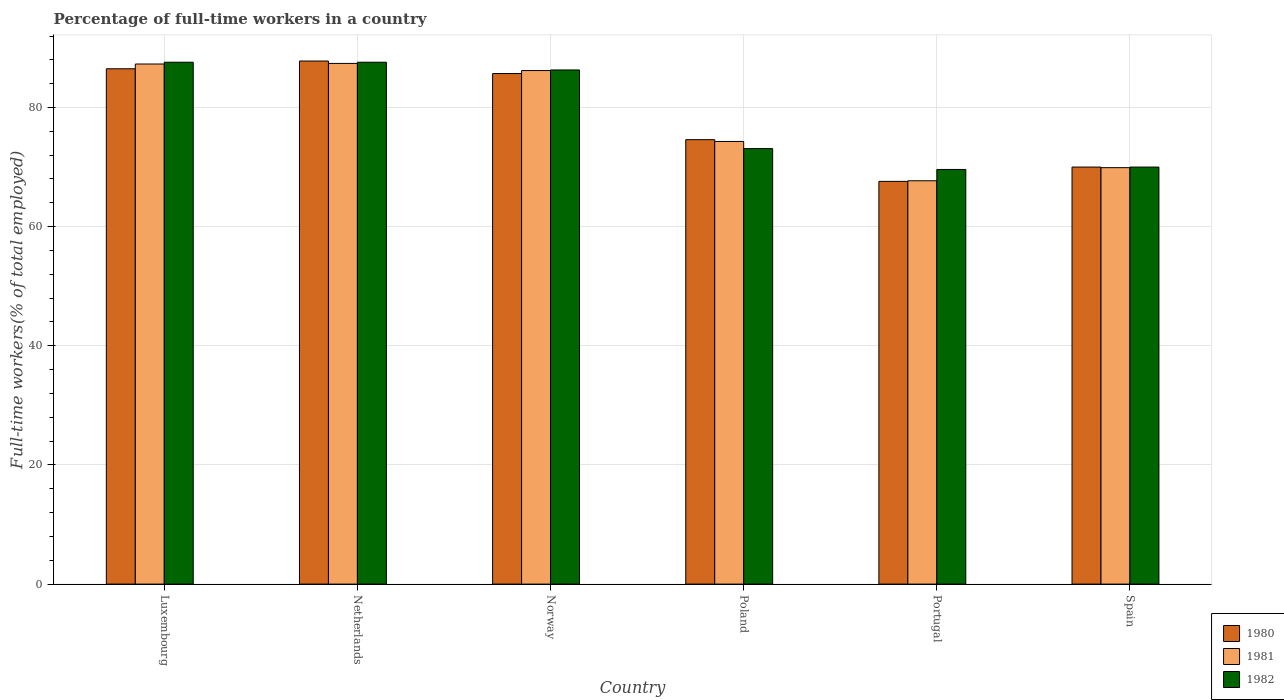How many different coloured bars are there?
Keep it short and to the point. 3. How many bars are there on the 6th tick from the right?
Provide a succinct answer. 3. What is the label of the 4th group of bars from the left?
Offer a very short reply. Poland. What is the percentage of full-time workers in 1982 in Norway?
Your answer should be very brief. 86.3. Across all countries, what is the maximum percentage of full-time workers in 1982?
Make the answer very short. 87.6. Across all countries, what is the minimum percentage of full-time workers in 1981?
Make the answer very short. 67.7. In which country was the percentage of full-time workers in 1982 maximum?
Provide a succinct answer. Luxembourg. In which country was the percentage of full-time workers in 1980 minimum?
Offer a very short reply. Portugal. What is the total percentage of full-time workers in 1981 in the graph?
Your response must be concise. 472.8. What is the difference between the percentage of full-time workers in 1980 in Norway and that in Spain?
Your answer should be compact. 15.7. What is the difference between the percentage of full-time workers in 1980 in Spain and the percentage of full-time workers in 1981 in Poland?
Give a very brief answer. -4.3. What is the average percentage of full-time workers in 1980 per country?
Provide a succinct answer. 78.7. What is the difference between the percentage of full-time workers of/in 1981 and percentage of full-time workers of/in 1980 in Portugal?
Provide a succinct answer. 0.1. What is the ratio of the percentage of full-time workers in 1980 in Poland to that in Spain?
Your response must be concise. 1.07. Is the percentage of full-time workers in 1981 in Luxembourg less than that in Spain?
Your response must be concise. No. What is the difference between the highest and the second highest percentage of full-time workers in 1981?
Offer a very short reply. -1.1. What is the difference between the highest and the lowest percentage of full-time workers in 1981?
Give a very brief answer. 19.7. What does the 3rd bar from the right in Luxembourg represents?
Make the answer very short. 1980. How many bars are there?
Offer a very short reply. 18. Are all the bars in the graph horizontal?
Offer a very short reply. No. Are the values on the major ticks of Y-axis written in scientific E-notation?
Make the answer very short. No. How are the legend labels stacked?
Offer a terse response. Vertical. What is the title of the graph?
Your answer should be compact. Percentage of full-time workers in a country. What is the label or title of the X-axis?
Offer a very short reply. Country. What is the label or title of the Y-axis?
Your answer should be very brief. Full-time workers(% of total employed). What is the Full-time workers(% of total employed) of 1980 in Luxembourg?
Ensure brevity in your answer.  86.5. What is the Full-time workers(% of total employed) of 1981 in Luxembourg?
Keep it short and to the point. 87.3. What is the Full-time workers(% of total employed) in 1982 in Luxembourg?
Provide a succinct answer. 87.6. What is the Full-time workers(% of total employed) of 1980 in Netherlands?
Provide a short and direct response. 87.8. What is the Full-time workers(% of total employed) of 1981 in Netherlands?
Offer a terse response. 87.4. What is the Full-time workers(% of total employed) of 1982 in Netherlands?
Provide a short and direct response. 87.6. What is the Full-time workers(% of total employed) in 1980 in Norway?
Offer a terse response. 85.7. What is the Full-time workers(% of total employed) in 1981 in Norway?
Ensure brevity in your answer.  86.2. What is the Full-time workers(% of total employed) in 1982 in Norway?
Provide a succinct answer. 86.3. What is the Full-time workers(% of total employed) in 1980 in Poland?
Provide a short and direct response. 74.6. What is the Full-time workers(% of total employed) of 1981 in Poland?
Ensure brevity in your answer.  74.3. What is the Full-time workers(% of total employed) of 1982 in Poland?
Provide a succinct answer. 73.1. What is the Full-time workers(% of total employed) in 1980 in Portugal?
Give a very brief answer. 67.6. What is the Full-time workers(% of total employed) in 1981 in Portugal?
Provide a succinct answer. 67.7. What is the Full-time workers(% of total employed) of 1982 in Portugal?
Your response must be concise. 69.6. What is the Full-time workers(% of total employed) of 1980 in Spain?
Your answer should be compact. 70. What is the Full-time workers(% of total employed) in 1981 in Spain?
Offer a very short reply. 69.9. What is the Full-time workers(% of total employed) of 1982 in Spain?
Provide a short and direct response. 70. Across all countries, what is the maximum Full-time workers(% of total employed) in 1980?
Provide a short and direct response. 87.8. Across all countries, what is the maximum Full-time workers(% of total employed) of 1981?
Offer a terse response. 87.4. Across all countries, what is the maximum Full-time workers(% of total employed) of 1982?
Provide a short and direct response. 87.6. Across all countries, what is the minimum Full-time workers(% of total employed) in 1980?
Offer a terse response. 67.6. Across all countries, what is the minimum Full-time workers(% of total employed) of 1981?
Ensure brevity in your answer.  67.7. Across all countries, what is the minimum Full-time workers(% of total employed) in 1982?
Provide a short and direct response. 69.6. What is the total Full-time workers(% of total employed) of 1980 in the graph?
Make the answer very short. 472.2. What is the total Full-time workers(% of total employed) of 1981 in the graph?
Your answer should be very brief. 472.8. What is the total Full-time workers(% of total employed) in 1982 in the graph?
Your answer should be very brief. 474.2. What is the difference between the Full-time workers(% of total employed) of 1980 in Luxembourg and that in Netherlands?
Give a very brief answer. -1.3. What is the difference between the Full-time workers(% of total employed) in 1981 in Luxembourg and that in Netherlands?
Your response must be concise. -0.1. What is the difference between the Full-time workers(% of total employed) of 1980 in Luxembourg and that in Norway?
Give a very brief answer. 0.8. What is the difference between the Full-time workers(% of total employed) of 1981 in Luxembourg and that in Norway?
Offer a very short reply. 1.1. What is the difference between the Full-time workers(% of total employed) of 1980 in Luxembourg and that in Poland?
Offer a very short reply. 11.9. What is the difference between the Full-time workers(% of total employed) in 1981 in Luxembourg and that in Poland?
Provide a succinct answer. 13. What is the difference between the Full-time workers(% of total employed) in 1982 in Luxembourg and that in Poland?
Give a very brief answer. 14.5. What is the difference between the Full-time workers(% of total employed) in 1980 in Luxembourg and that in Portugal?
Ensure brevity in your answer.  18.9. What is the difference between the Full-time workers(% of total employed) of 1981 in Luxembourg and that in Portugal?
Keep it short and to the point. 19.6. What is the difference between the Full-time workers(% of total employed) of 1982 in Luxembourg and that in Portugal?
Provide a short and direct response. 18. What is the difference between the Full-time workers(% of total employed) in 1981 in Luxembourg and that in Spain?
Offer a terse response. 17.4. What is the difference between the Full-time workers(% of total employed) in 1982 in Luxembourg and that in Spain?
Give a very brief answer. 17.6. What is the difference between the Full-time workers(% of total employed) of 1980 in Netherlands and that in Norway?
Your response must be concise. 2.1. What is the difference between the Full-time workers(% of total employed) in 1982 in Netherlands and that in Norway?
Give a very brief answer. 1.3. What is the difference between the Full-time workers(% of total employed) in 1980 in Netherlands and that in Poland?
Your answer should be compact. 13.2. What is the difference between the Full-time workers(% of total employed) of 1981 in Netherlands and that in Poland?
Keep it short and to the point. 13.1. What is the difference between the Full-time workers(% of total employed) in 1980 in Netherlands and that in Portugal?
Provide a short and direct response. 20.2. What is the difference between the Full-time workers(% of total employed) of 1981 in Netherlands and that in Portugal?
Your response must be concise. 19.7. What is the difference between the Full-time workers(% of total employed) in 1982 in Netherlands and that in Portugal?
Offer a very short reply. 18. What is the difference between the Full-time workers(% of total employed) of 1981 in Netherlands and that in Spain?
Offer a terse response. 17.5. What is the difference between the Full-time workers(% of total employed) of 1980 in Norway and that in Poland?
Offer a very short reply. 11.1. What is the difference between the Full-time workers(% of total employed) in 1982 in Norway and that in Poland?
Give a very brief answer. 13.2. What is the difference between the Full-time workers(% of total employed) of 1982 in Norway and that in Portugal?
Keep it short and to the point. 16.7. What is the difference between the Full-time workers(% of total employed) in 1980 in Poland and that in Portugal?
Keep it short and to the point. 7. What is the difference between the Full-time workers(% of total employed) of 1981 in Poland and that in Spain?
Keep it short and to the point. 4.4. What is the difference between the Full-time workers(% of total employed) in 1980 in Portugal and that in Spain?
Offer a very short reply. -2.4. What is the difference between the Full-time workers(% of total employed) of 1981 in Portugal and that in Spain?
Give a very brief answer. -2.2. What is the difference between the Full-time workers(% of total employed) in 1982 in Portugal and that in Spain?
Your answer should be compact. -0.4. What is the difference between the Full-time workers(% of total employed) of 1980 in Luxembourg and the Full-time workers(% of total employed) of 1981 in Netherlands?
Provide a short and direct response. -0.9. What is the difference between the Full-time workers(% of total employed) in 1980 in Luxembourg and the Full-time workers(% of total employed) in 1981 in Norway?
Offer a very short reply. 0.3. What is the difference between the Full-time workers(% of total employed) in 1980 in Luxembourg and the Full-time workers(% of total employed) in 1982 in Norway?
Your answer should be compact. 0.2. What is the difference between the Full-time workers(% of total employed) in 1981 in Luxembourg and the Full-time workers(% of total employed) in 1982 in Norway?
Give a very brief answer. 1. What is the difference between the Full-time workers(% of total employed) of 1980 in Luxembourg and the Full-time workers(% of total employed) of 1982 in Poland?
Give a very brief answer. 13.4. What is the difference between the Full-time workers(% of total employed) in 1981 in Luxembourg and the Full-time workers(% of total employed) in 1982 in Poland?
Your answer should be compact. 14.2. What is the difference between the Full-time workers(% of total employed) of 1980 in Luxembourg and the Full-time workers(% of total employed) of 1981 in Portugal?
Provide a succinct answer. 18.8. What is the difference between the Full-time workers(% of total employed) of 1981 in Luxembourg and the Full-time workers(% of total employed) of 1982 in Portugal?
Provide a succinct answer. 17.7. What is the difference between the Full-time workers(% of total employed) of 1980 in Netherlands and the Full-time workers(% of total employed) of 1982 in Norway?
Your answer should be compact. 1.5. What is the difference between the Full-time workers(% of total employed) in 1980 in Netherlands and the Full-time workers(% of total employed) in 1981 in Poland?
Ensure brevity in your answer.  13.5. What is the difference between the Full-time workers(% of total employed) in 1981 in Netherlands and the Full-time workers(% of total employed) in 1982 in Poland?
Make the answer very short. 14.3. What is the difference between the Full-time workers(% of total employed) of 1980 in Netherlands and the Full-time workers(% of total employed) of 1981 in Portugal?
Offer a terse response. 20.1. What is the difference between the Full-time workers(% of total employed) in 1981 in Netherlands and the Full-time workers(% of total employed) in 1982 in Portugal?
Your response must be concise. 17.8. What is the difference between the Full-time workers(% of total employed) in 1980 in Netherlands and the Full-time workers(% of total employed) in 1981 in Spain?
Provide a short and direct response. 17.9. What is the difference between the Full-time workers(% of total employed) of 1980 in Norway and the Full-time workers(% of total employed) of 1982 in Poland?
Offer a terse response. 12.6. What is the difference between the Full-time workers(% of total employed) of 1980 in Norway and the Full-time workers(% of total employed) of 1982 in Portugal?
Make the answer very short. 16.1. What is the difference between the Full-time workers(% of total employed) in 1981 in Norway and the Full-time workers(% of total employed) in 1982 in Portugal?
Your answer should be very brief. 16.6. What is the difference between the Full-time workers(% of total employed) in 1981 in Norway and the Full-time workers(% of total employed) in 1982 in Spain?
Ensure brevity in your answer.  16.2. What is the difference between the Full-time workers(% of total employed) in 1980 in Poland and the Full-time workers(% of total employed) in 1982 in Portugal?
Give a very brief answer. 5. What is the difference between the Full-time workers(% of total employed) of 1980 in Poland and the Full-time workers(% of total employed) of 1981 in Spain?
Keep it short and to the point. 4.7. What is the difference between the Full-time workers(% of total employed) in 1980 in Portugal and the Full-time workers(% of total employed) in 1981 in Spain?
Your answer should be very brief. -2.3. What is the difference between the Full-time workers(% of total employed) of 1981 in Portugal and the Full-time workers(% of total employed) of 1982 in Spain?
Your response must be concise. -2.3. What is the average Full-time workers(% of total employed) in 1980 per country?
Keep it short and to the point. 78.7. What is the average Full-time workers(% of total employed) in 1981 per country?
Offer a very short reply. 78.8. What is the average Full-time workers(% of total employed) of 1982 per country?
Provide a short and direct response. 79.03. What is the difference between the Full-time workers(% of total employed) in 1980 and Full-time workers(% of total employed) in 1981 in Luxembourg?
Keep it short and to the point. -0.8. What is the difference between the Full-time workers(% of total employed) of 1980 and Full-time workers(% of total employed) of 1982 in Luxembourg?
Your answer should be compact. -1.1. What is the difference between the Full-time workers(% of total employed) of 1981 and Full-time workers(% of total employed) of 1982 in Luxembourg?
Your answer should be compact. -0.3. What is the difference between the Full-time workers(% of total employed) in 1981 and Full-time workers(% of total employed) in 1982 in Netherlands?
Offer a terse response. -0.2. What is the difference between the Full-time workers(% of total employed) of 1980 and Full-time workers(% of total employed) of 1982 in Norway?
Give a very brief answer. -0.6. What is the difference between the Full-time workers(% of total employed) in 1981 and Full-time workers(% of total employed) in 1982 in Norway?
Ensure brevity in your answer.  -0.1. What is the difference between the Full-time workers(% of total employed) in 1980 and Full-time workers(% of total employed) in 1981 in Poland?
Your answer should be compact. 0.3. What is the difference between the Full-time workers(% of total employed) in 1980 and Full-time workers(% of total employed) in 1982 in Poland?
Ensure brevity in your answer.  1.5. What is the difference between the Full-time workers(% of total employed) in 1980 and Full-time workers(% of total employed) in 1982 in Portugal?
Make the answer very short. -2. What is the difference between the Full-time workers(% of total employed) in 1981 and Full-time workers(% of total employed) in 1982 in Spain?
Give a very brief answer. -0.1. What is the ratio of the Full-time workers(% of total employed) in 1980 in Luxembourg to that in Netherlands?
Make the answer very short. 0.99. What is the ratio of the Full-time workers(% of total employed) in 1980 in Luxembourg to that in Norway?
Give a very brief answer. 1.01. What is the ratio of the Full-time workers(% of total employed) in 1981 in Luxembourg to that in Norway?
Your answer should be compact. 1.01. What is the ratio of the Full-time workers(% of total employed) in 1982 in Luxembourg to that in Norway?
Your answer should be compact. 1.02. What is the ratio of the Full-time workers(% of total employed) of 1980 in Luxembourg to that in Poland?
Give a very brief answer. 1.16. What is the ratio of the Full-time workers(% of total employed) in 1981 in Luxembourg to that in Poland?
Provide a short and direct response. 1.18. What is the ratio of the Full-time workers(% of total employed) in 1982 in Luxembourg to that in Poland?
Give a very brief answer. 1.2. What is the ratio of the Full-time workers(% of total employed) of 1980 in Luxembourg to that in Portugal?
Keep it short and to the point. 1.28. What is the ratio of the Full-time workers(% of total employed) of 1981 in Luxembourg to that in Portugal?
Provide a succinct answer. 1.29. What is the ratio of the Full-time workers(% of total employed) in 1982 in Luxembourg to that in Portugal?
Keep it short and to the point. 1.26. What is the ratio of the Full-time workers(% of total employed) of 1980 in Luxembourg to that in Spain?
Provide a short and direct response. 1.24. What is the ratio of the Full-time workers(% of total employed) in 1981 in Luxembourg to that in Spain?
Your response must be concise. 1.25. What is the ratio of the Full-time workers(% of total employed) in 1982 in Luxembourg to that in Spain?
Offer a terse response. 1.25. What is the ratio of the Full-time workers(% of total employed) in 1980 in Netherlands to that in Norway?
Offer a very short reply. 1.02. What is the ratio of the Full-time workers(% of total employed) in 1981 in Netherlands to that in Norway?
Give a very brief answer. 1.01. What is the ratio of the Full-time workers(% of total employed) in 1982 in Netherlands to that in Norway?
Make the answer very short. 1.02. What is the ratio of the Full-time workers(% of total employed) in 1980 in Netherlands to that in Poland?
Your answer should be compact. 1.18. What is the ratio of the Full-time workers(% of total employed) in 1981 in Netherlands to that in Poland?
Give a very brief answer. 1.18. What is the ratio of the Full-time workers(% of total employed) in 1982 in Netherlands to that in Poland?
Offer a terse response. 1.2. What is the ratio of the Full-time workers(% of total employed) of 1980 in Netherlands to that in Portugal?
Provide a short and direct response. 1.3. What is the ratio of the Full-time workers(% of total employed) of 1981 in Netherlands to that in Portugal?
Provide a succinct answer. 1.29. What is the ratio of the Full-time workers(% of total employed) of 1982 in Netherlands to that in Portugal?
Ensure brevity in your answer.  1.26. What is the ratio of the Full-time workers(% of total employed) of 1980 in Netherlands to that in Spain?
Keep it short and to the point. 1.25. What is the ratio of the Full-time workers(% of total employed) of 1981 in Netherlands to that in Spain?
Your response must be concise. 1.25. What is the ratio of the Full-time workers(% of total employed) of 1982 in Netherlands to that in Spain?
Keep it short and to the point. 1.25. What is the ratio of the Full-time workers(% of total employed) in 1980 in Norway to that in Poland?
Keep it short and to the point. 1.15. What is the ratio of the Full-time workers(% of total employed) in 1981 in Norway to that in Poland?
Offer a very short reply. 1.16. What is the ratio of the Full-time workers(% of total employed) of 1982 in Norway to that in Poland?
Offer a terse response. 1.18. What is the ratio of the Full-time workers(% of total employed) in 1980 in Norway to that in Portugal?
Offer a terse response. 1.27. What is the ratio of the Full-time workers(% of total employed) of 1981 in Norway to that in Portugal?
Keep it short and to the point. 1.27. What is the ratio of the Full-time workers(% of total employed) in 1982 in Norway to that in Portugal?
Your answer should be compact. 1.24. What is the ratio of the Full-time workers(% of total employed) in 1980 in Norway to that in Spain?
Your answer should be very brief. 1.22. What is the ratio of the Full-time workers(% of total employed) of 1981 in Norway to that in Spain?
Make the answer very short. 1.23. What is the ratio of the Full-time workers(% of total employed) in 1982 in Norway to that in Spain?
Keep it short and to the point. 1.23. What is the ratio of the Full-time workers(% of total employed) of 1980 in Poland to that in Portugal?
Your answer should be compact. 1.1. What is the ratio of the Full-time workers(% of total employed) in 1981 in Poland to that in Portugal?
Ensure brevity in your answer.  1.1. What is the ratio of the Full-time workers(% of total employed) in 1982 in Poland to that in Portugal?
Make the answer very short. 1.05. What is the ratio of the Full-time workers(% of total employed) in 1980 in Poland to that in Spain?
Offer a very short reply. 1.07. What is the ratio of the Full-time workers(% of total employed) in 1981 in Poland to that in Spain?
Your response must be concise. 1.06. What is the ratio of the Full-time workers(% of total employed) in 1982 in Poland to that in Spain?
Provide a succinct answer. 1.04. What is the ratio of the Full-time workers(% of total employed) of 1980 in Portugal to that in Spain?
Your answer should be compact. 0.97. What is the ratio of the Full-time workers(% of total employed) of 1981 in Portugal to that in Spain?
Offer a very short reply. 0.97. What is the ratio of the Full-time workers(% of total employed) in 1982 in Portugal to that in Spain?
Provide a short and direct response. 0.99. What is the difference between the highest and the second highest Full-time workers(% of total employed) of 1982?
Offer a terse response. 0. What is the difference between the highest and the lowest Full-time workers(% of total employed) of 1980?
Offer a terse response. 20.2. What is the difference between the highest and the lowest Full-time workers(% of total employed) in 1981?
Make the answer very short. 19.7. What is the difference between the highest and the lowest Full-time workers(% of total employed) of 1982?
Offer a very short reply. 18. 